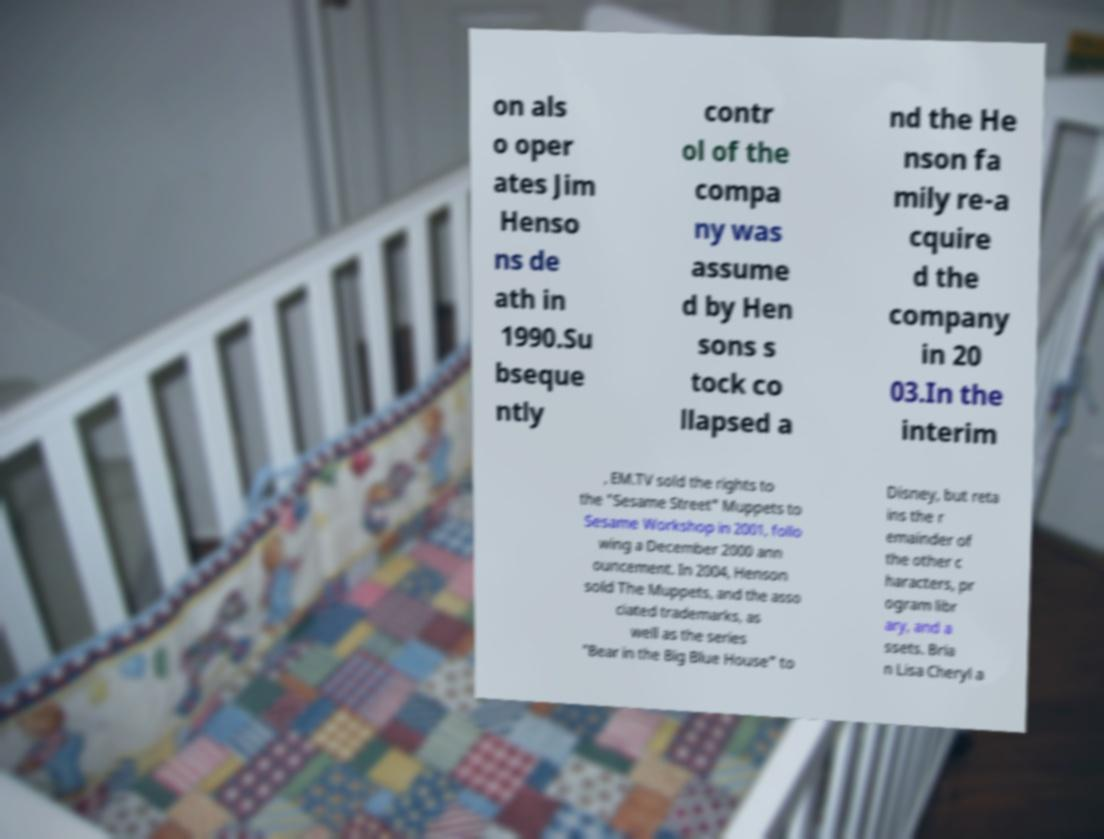Could you assist in decoding the text presented in this image and type it out clearly? on als o oper ates Jim Henso ns de ath in 1990.Su bseque ntly contr ol of the compa ny was assume d by Hen sons s tock co llapsed a nd the He nson fa mily re-a cquire d the company in 20 03.In the interim , EM.TV sold the rights to the "Sesame Street" Muppets to Sesame Workshop in 2001, follo wing a December 2000 ann ouncement. In 2004, Henson sold The Muppets, and the asso ciated trademarks, as well as the series "Bear in the Big Blue House" to Disney, but reta ins the r emainder of the other c haracters, pr ogram libr ary, and a ssets. Bria n Lisa Cheryl a 